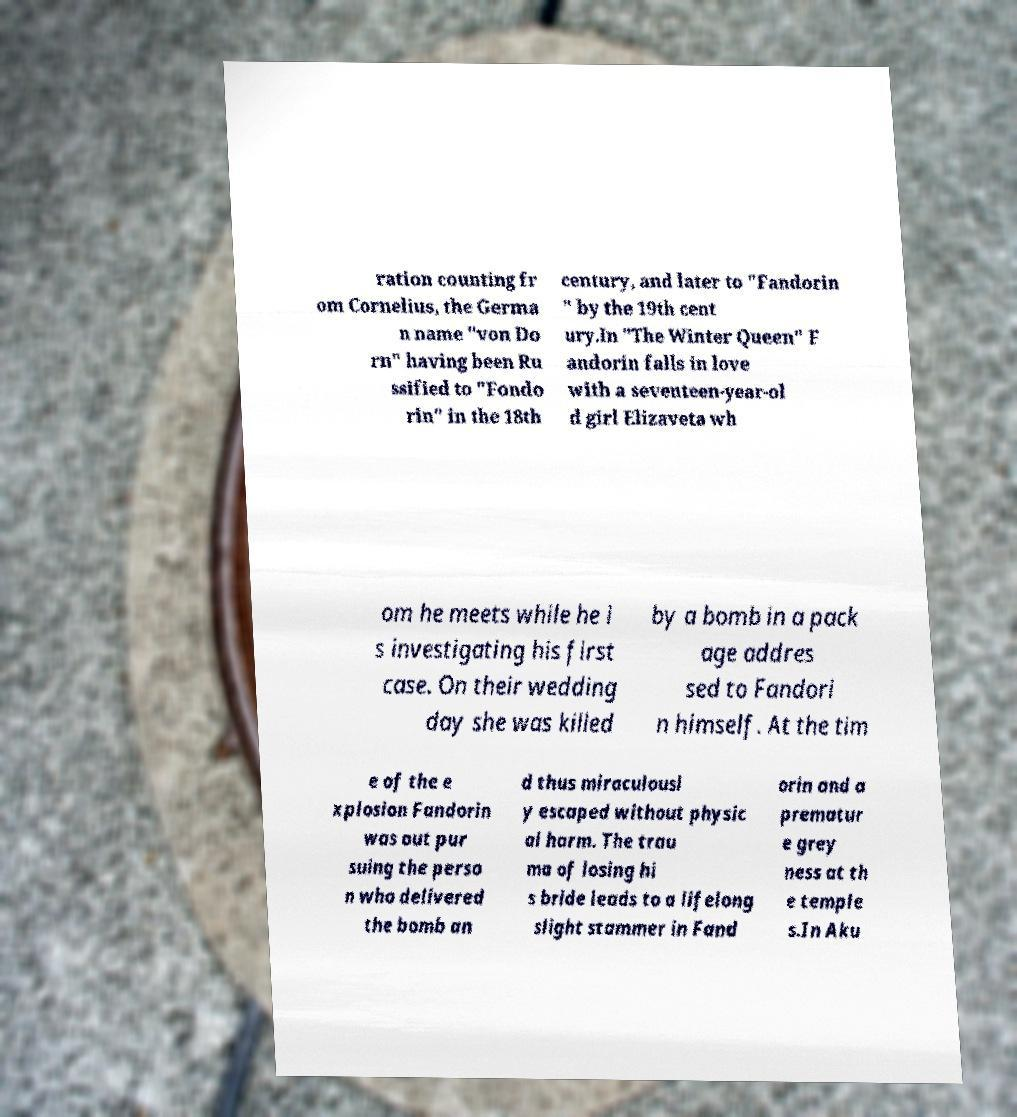Please read and relay the text visible in this image. What does it say? ration counting fr om Cornelius, the Germa n name "von Do rn" having been Ru ssified to "Fondo rin" in the 18th century, and later to "Fandorin " by the 19th cent ury.In "The Winter Queen" F andorin falls in love with a seventeen-year-ol d girl Elizaveta wh om he meets while he i s investigating his first case. On their wedding day she was killed by a bomb in a pack age addres sed to Fandori n himself. At the tim e of the e xplosion Fandorin was out pur suing the perso n who delivered the bomb an d thus miraculousl y escaped without physic al harm. The trau ma of losing hi s bride leads to a lifelong slight stammer in Fand orin and a prematur e grey ness at th e temple s.In Aku 